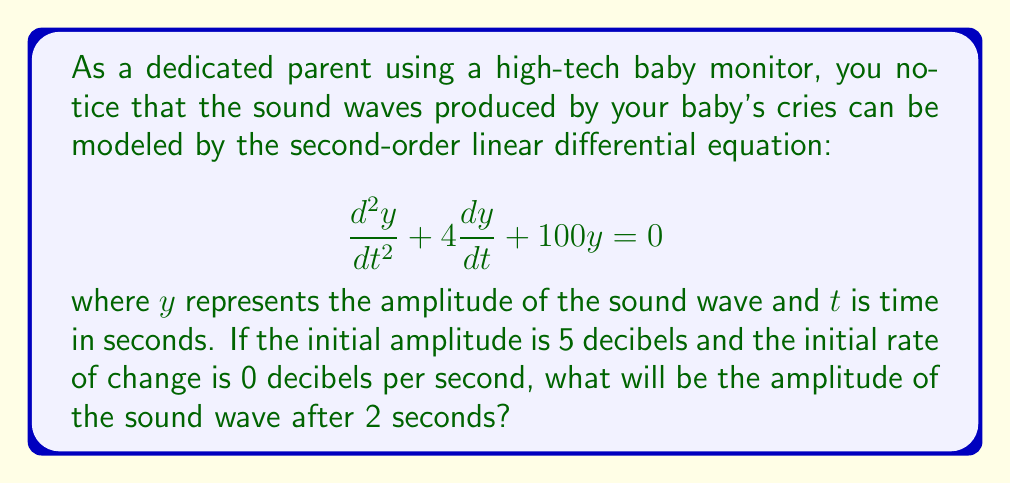Provide a solution to this math problem. To solve this problem, we need to follow these steps:

1) The general solution for this second-order linear differential equation is:

   $$y(t) = e^{-2t}(A\cos(8t) + B\sin(8t))$$

   where $A$ and $B$ are constants determined by the initial conditions.

2) Given initial conditions:
   - $y(0) = 5$ (initial amplitude)
   - $y'(0) = 0$ (initial rate of change)

3) Using the initial condition $y(0) = 5$:
   
   $$5 = e^{-2(0)}(A\cos(8(0)) + B\sin(8(0)))$$
   $$5 = A$$

4) To use the second initial condition, we need to find $y'(t)$:
   
   $$y'(t) = -2e^{-2t}(A\cos(8t) + B\sin(8t)) + e^{-2t}(-8A\sin(8t) + 8B\cos(8t))$$

5) Apply the initial condition $y'(0) = 0$:

   $$0 = -2e^{-2(0)}(5\cos(8(0)) + B\sin(8(0))) + e^{-2(0)}(-8(5)\sin(8(0)) + 8B\cos(8(0)))$$
   $$0 = -10 + 8B$$
   $$B = \frac{5}{4}$$

6) Now we have the complete solution:

   $$y(t) = e^{-2t}(5\cos(8t) + \frac{5}{4}\sin(8t))$$

7) To find the amplitude after 2 seconds, we substitute $t = 2$:

   $$y(2) = e^{-2(2)}(5\cos(16) + \frac{5}{4}\sin(16))$$
   $$y(2) = e^{-4}(5\cos(16) + \frac{5}{4}\sin(16))$$

8) Calculating this value:

   $$y(2) \approx 0.018\text{ decibels}$$
Answer: The amplitude of the sound wave after 2 seconds will be approximately 0.018 decibels. 